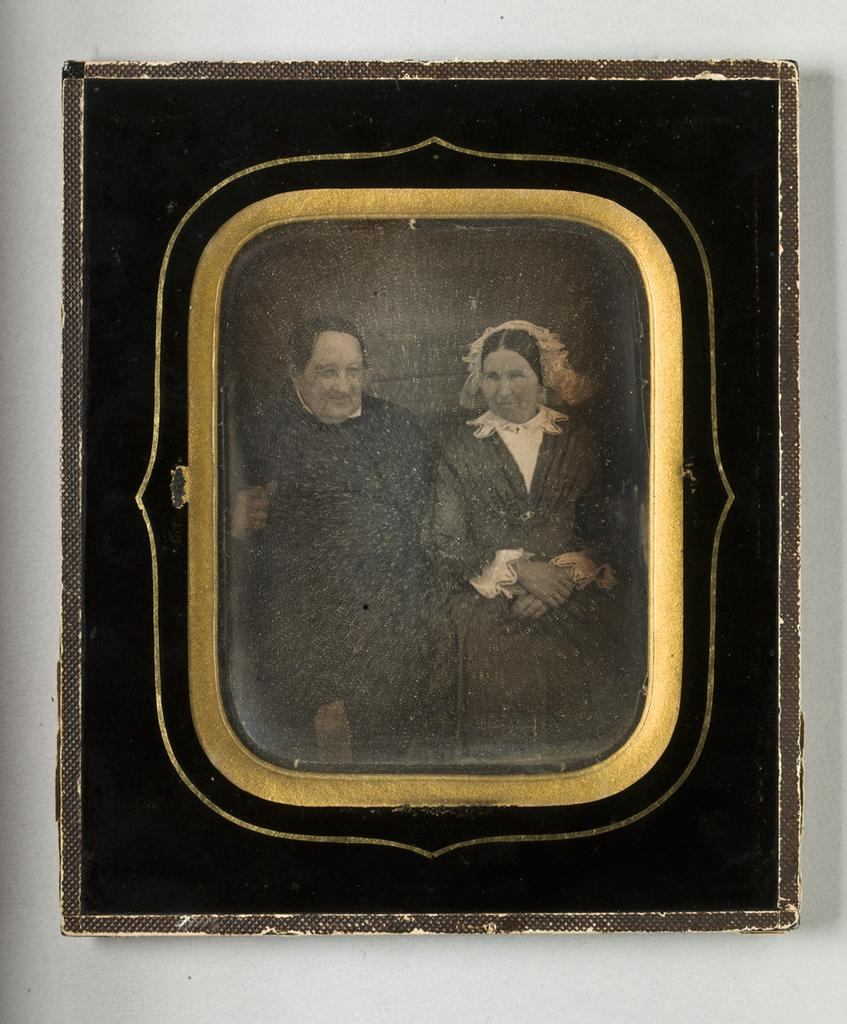What object is visible in the center of the image? There is a photo frame in the image, and it is located in the center. Where is the photo frame placed? The photo frame is placed on the wall. What type of popcorn is being served at the baby's birthday party in the image? There is no popcorn, baby, or birthday party present in the image; it only features a photo frame on the wall. 